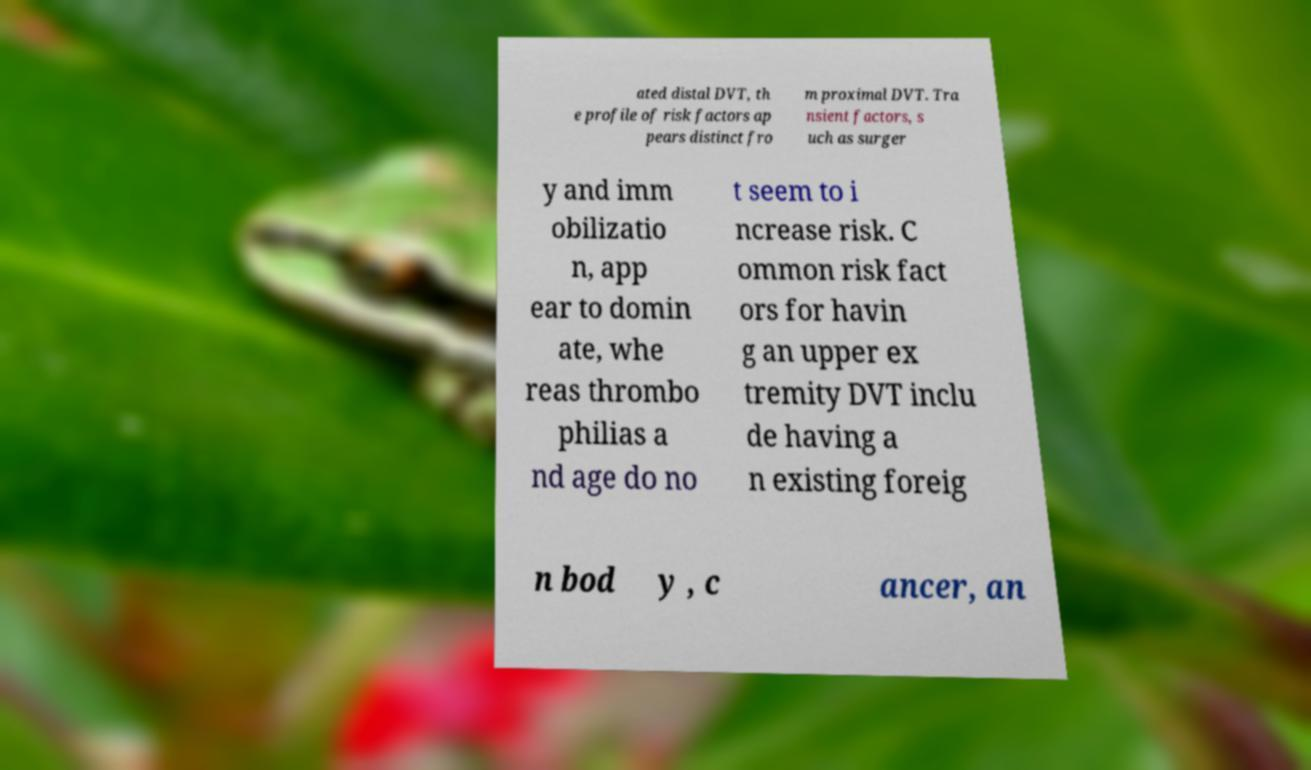I need the written content from this picture converted into text. Can you do that? ated distal DVT, th e profile of risk factors ap pears distinct fro m proximal DVT. Tra nsient factors, s uch as surger y and imm obilizatio n, app ear to domin ate, whe reas thrombo philias a nd age do no t seem to i ncrease risk. C ommon risk fact ors for havin g an upper ex tremity DVT inclu de having a n existing foreig n bod y , c ancer, an 